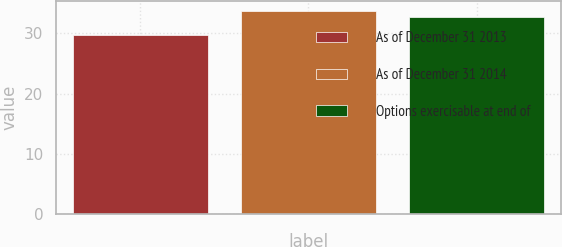<chart> <loc_0><loc_0><loc_500><loc_500><bar_chart><fcel>As of December 31 2013<fcel>As of December 31 2014<fcel>Options exercisable at end of<nl><fcel>29.75<fcel>33.72<fcel>32.67<nl></chart> 